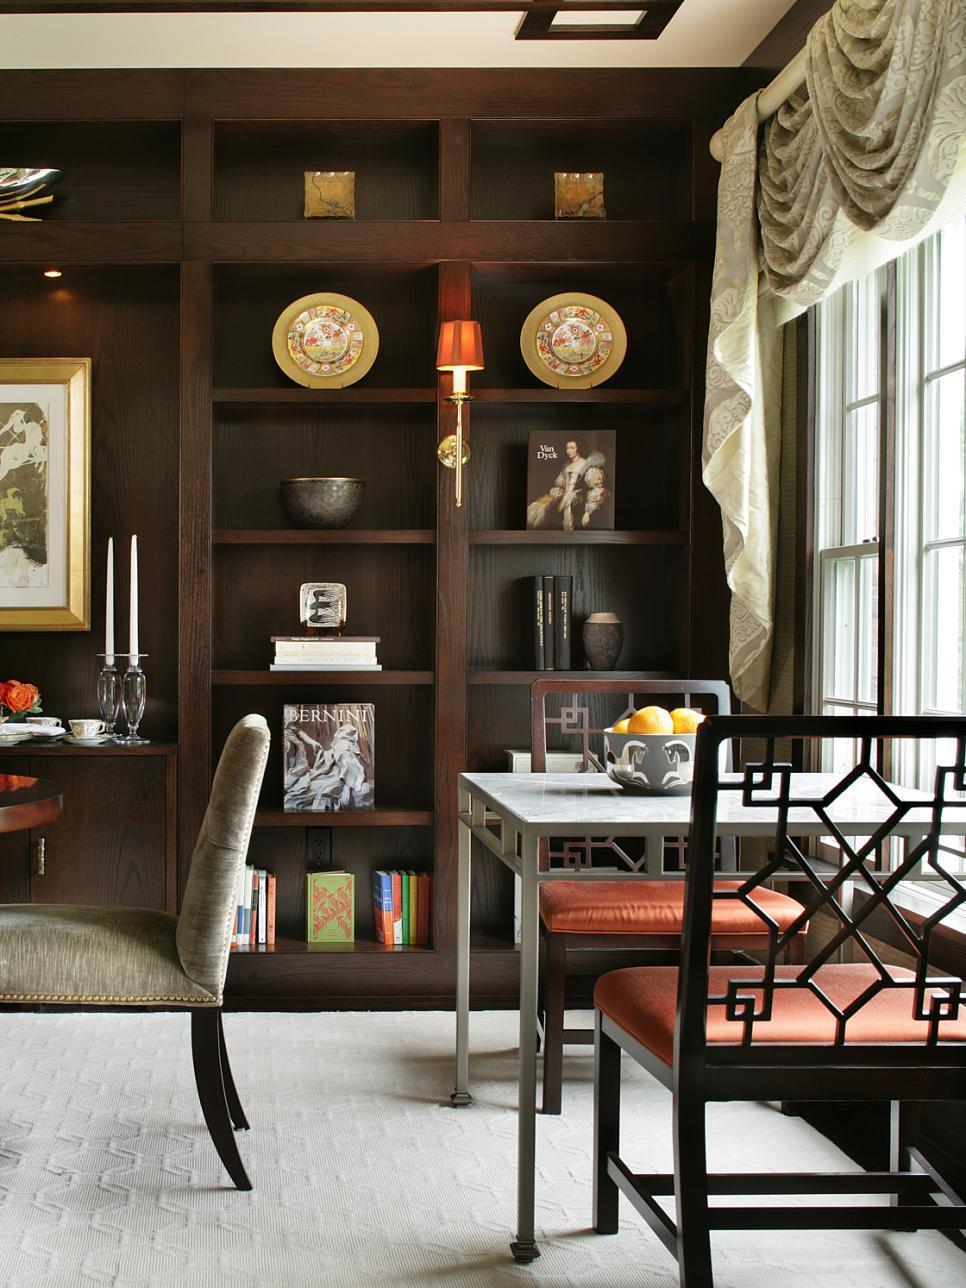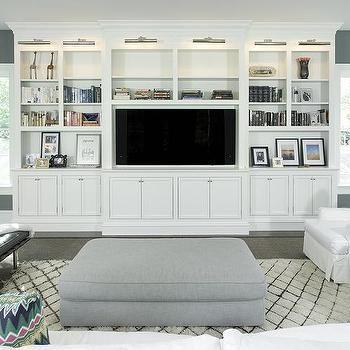The first image is the image on the left, the second image is the image on the right. Examine the images to the left and right. Is the description "In at least one image, a fireplace with an overhead television is flanked by shelves." accurate? Answer yes or no. No. The first image is the image on the left, the second image is the image on the right. Assess this claim about the two images: "There is a TV above a fireplace in the right image.". Correct or not? Answer yes or no. No. 